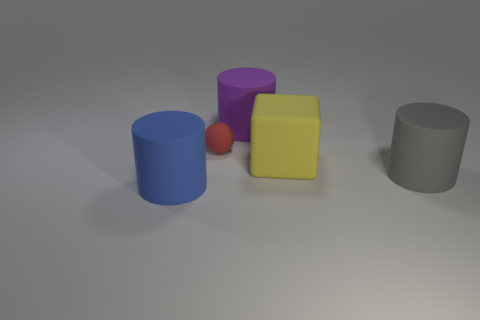Subtract 1 cylinders. How many cylinders are left? 2 Add 4 tiny red matte objects. How many objects exist? 9 Subtract all cylinders. How many objects are left? 2 Subtract all big blue things. Subtract all red matte objects. How many objects are left? 3 Add 2 rubber cylinders. How many rubber cylinders are left? 5 Add 2 purple objects. How many purple objects exist? 3 Subtract 0 green cylinders. How many objects are left? 5 